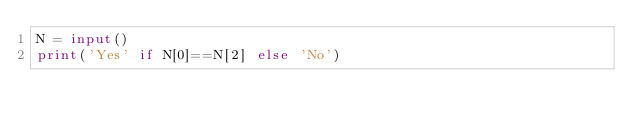Convert code to text. <code><loc_0><loc_0><loc_500><loc_500><_Python_>N = input()
print('Yes' if N[0]==N[2] else 'No')</code> 